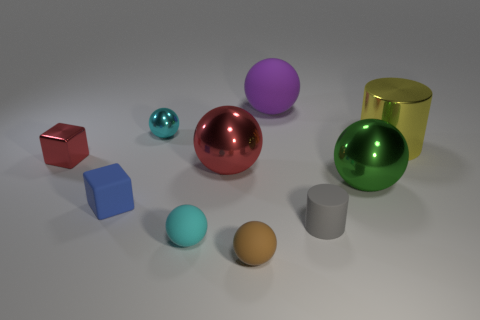What time of day does the lighting in the scene suggest? The lighting in the scene does not distinctly suggest any specific time of day, as it appears to be studio lighting meant to highlight the shiny surfaces of the objects without clear indicators such as shadows or sunlight angles typically associated with natural lighting. 